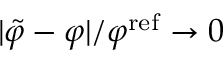Convert formula to latex. <formula><loc_0><loc_0><loc_500><loc_500>| \tilde { \varphi } - \varphi | / \varphi ^ { r e f } \to 0</formula> 